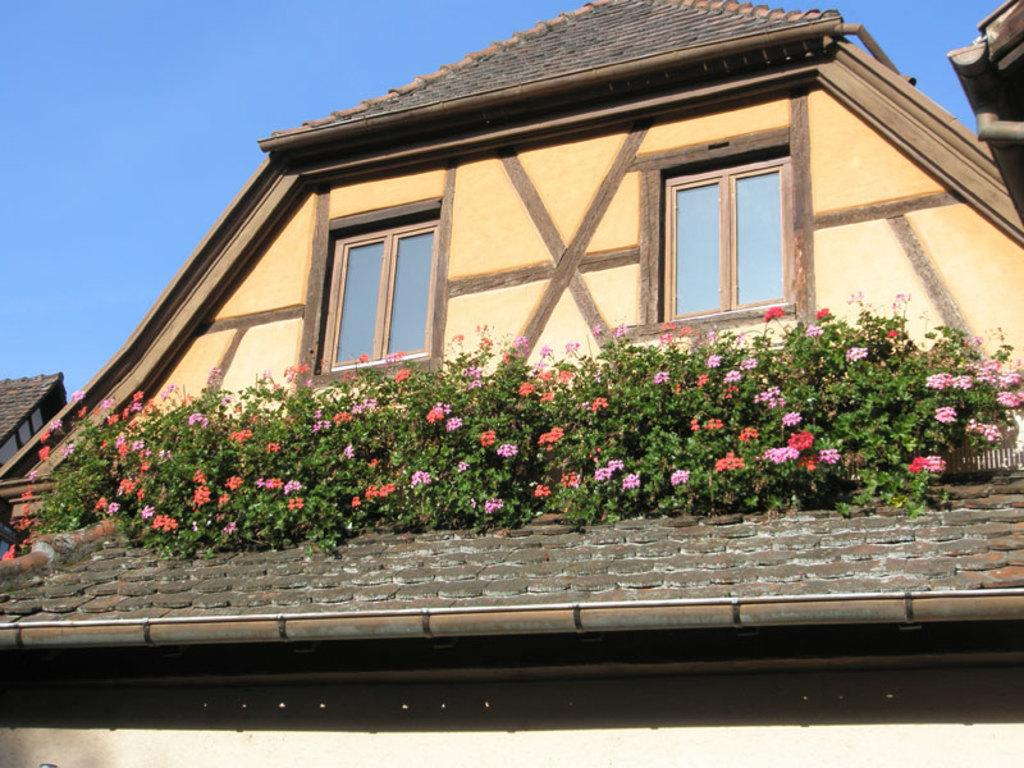What is the main structure in the image? There is a building in the image. What is on top of the building? There are flowers and plants on the roof of the building. What can be seen in the background of the image? The sky is visible in the background of the image. How many patches of pies can be seen on the roof of the building? There are no pies present on the roof of the building; it features flowers and plants. What type of nose is visible on the building in the image? There is no nose present on the building in the image. 